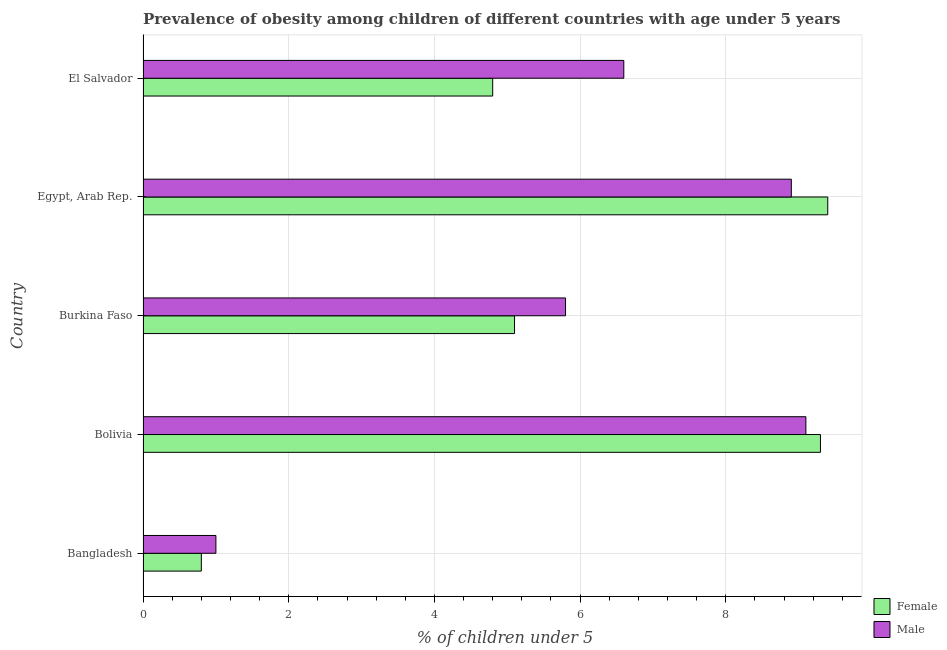How many groups of bars are there?
Your response must be concise. 5. Are the number of bars on each tick of the Y-axis equal?
Give a very brief answer. Yes. In how many cases, is the number of bars for a given country not equal to the number of legend labels?
Provide a short and direct response. 0. Across all countries, what is the maximum percentage of obese female children?
Provide a short and direct response. 9.4. In which country was the percentage of obese female children maximum?
Ensure brevity in your answer.  Egypt, Arab Rep. In which country was the percentage of obese female children minimum?
Give a very brief answer. Bangladesh. What is the total percentage of obese male children in the graph?
Provide a succinct answer. 31.4. What is the difference between the percentage of obese female children in Bangladesh and that in Egypt, Arab Rep.?
Ensure brevity in your answer.  -8.6. What is the difference between the percentage of obese female children in Bolivia and the percentage of obese male children in Burkina Faso?
Make the answer very short. 3.5. What is the average percentage of obese male children per country?
Your answer should be compact. 6.28. What is the difference between the percentage of obese male children and percentage of obese female children in Bangladesh?
Offer a very short reply. 0.2. What is the ratio of the percentage of obese male children in Burkina Faso to that in Egypt, Arab Rep.?
Ensure brevity in your answer.  0.65. What is the difference between the highest and the lowest percentage of obese female children?
Provide a short and direct response. 8.6. Is the sum of the percentage of obese female children in Bangladesh and Bolivia greater than the maximum percentage of obese male children across all countries?
Offer a very short reply. Yes. Are all the bars in the graph horizontal?
Make the answer very short. Yes. What is the difference between two consecutive major ticks on the X-axis?
Your response must be concise. 2. Does the graph contain any zero values?
Ensure brevity in your answer.  No. Where does the legend appear in the graph?
Make the answer very short. Bottom right. How many legend labels are there?
Give a very brief answer. 2. What is the title of the graph?
Keep it short and to the point. Prevalence of obesity among children of different countries with age under 5 years. What is the label or title of the X-axis?
Provide a short and direct response.  % of children under 5. What is the label or title of the Y-axis?
Your answer should be very brief. Country. What is the  % of children under 5 of Female in Bangladesh?
Provide a short and direct response. 0.8. What is the  % of children under 5 in Male in Bangladesh?
Give a very brief answer. 1. What is the  % of children under 5 in Female in Bolivia?
Offer a very short reply. 9.3. What is the  % of children under 5 in Male in Bolivia?
Your response must be concise. 9.1. What is the  % of children under 5 of Female in Burkina Faso?
Your answer should be compact. 5.1. What is the  % of children under 5 in Male in Burkina Faso?
Your response must be concise. 5.8. What is the  % of children under 5 in Female in Egypt, Arab Rep.?
Your answer should be very brief. 9.4. What is the  % of children under 5 in Male in Egypt, Arab Rep.?
Ensure brevity in your answer.  8.9. What is the  % of children under 5 of Female in El Salvador?
Offer a very short reply. 4.8. What is the  % of children under 5 of Male in El Salvador?
Provide a short and direct response. 6.6. Across all countries, what is the maximum  % of children under 5 in Female?
Keep it short and to the point. 9.4. Across all countries, what is the maximum  % of children under 5 in Male?
Your answer should be compact. 9.1. Across all countries, what is the minimum  % of children under 5 in Female?
Your answer should be compact. 0.8. Across all countries, what is the minimum  % of children under 5 of Male?
Keep it short and to the point. 1. What is the total  % of children under 5 in Female in the graph?
Offer a terse response. 29.4. What is the total  % of children under 5 in Male in the graph?
Offer a very short reply. 31.4. What is the difference between the  % of children under 5 in Female in Bangladesh and that in Bolivia?
Make the answer very short. -8.5. What is the difference between the  % of children under 5 of Female in Bangladesh and that in Burkina Faso?
Your answer should be very brief. -4.3. What is the difference between the  % of children under 5 of Male in Bangladesh and that in Egypt, Arab Rep.?
Provide a succinct answer. -7.9. What is the difference between the  % of children under 5 of Female in Bolivia and that in El Salvador?
Your answer should be very brief. 4.5. What is the difference between the  % of children under 5 of Male in Bolivia and that in El Salvador?
Provide a succinct answer. 2.5. What is the difference between the  % of children under 5 of Female in Burkina Faso and that in Egypt, Arab Rep.?
Provide a short and direct response. -4.3. What is the difference between the  % of children under 5 in Male in Burkina Faso and that in Egypt, Arab Rep.?
Provide a succinct answer. -3.1. What is the difference between the  % of children under 5 in Female in Burkina Faso and that in El Salvador?
Provide a succinct answer. 0.3. What is the difference between the  % of children under 5 in Female in Egypt, Arab Rep. and that in El Salvador?
Ensure brevity in your answer.  4.6. What is the difference between the  % of children under 5 in Female in Bangladesh and the  % of children under 5 in Male in Burkina Faso?
Keep it short and to the point. -5. What is the difference between the  % of children under 5 of Female in Bangladesh and the  % of children under 5 of Male in El Salvador?
Offer a very short reply. -5.8. What is the difference between the  % of children under 5 in Female in Bolivia and the  % of children under 5 in Male in Egypt, Arab Rep.?
Your answer should be very brief. 0.4. What is the difference between the  % of children under 5 of Female in Burkina Faso and the  % of children under 5 of Male in El Salvador?
Offer a terse response. -1.5. What is the average  % of children under 5 in Female per country?
Provide a succinct answer. 5.88. What is the average  % of children under 5 of Male per country?
Provide a short and direct response. 6.28. What is the difference between the  % of children under 5 of Female and  % of children under 5 of Male in Bangladesh?
Your response must be concise. -0.2. What is the difference between the  % of children under 5 in Female and  % of children under 5 in Male in Bolivia?
Your answer should be very brief. 0.2. What is the difference between the  % of children under 5 of Female and  % of children under 5 of Male in Egypt, Arab Rep.?
Ensure brevity in your answer.  0.5. What is the difference between the  % of children under 5 of Female and  % of children under 5 of Male in El Salvador?
Your answer should be very brief. -1.8. What is the ratio of the  % of children under 5 of Female in Bangladesh to that in Bolivia?
Your answer should be very brief. 0.09. What is the ratio of the  % of children under 5 of Male in Bangladesh to that in Bolivia?
Provide a short and direct response. 0.11. What is the ratio of the  % of children under 5 of Female in Bangladesh to that in Burkina Faso?
Make the answer very short. 0.16. What is the ratio of the  % of children under 5 in Male in Bangladesh to that in Burkina Faso?
Provide a short and direct response. 0.17. What is the ratio of the  % of children under 5 in Female in Bangladesh to that in Egypt, Arab Rep.?
Provide a short and direct response. 0.09. What is the ratio of the  % of children under 5 in Male in Bangladesh to that in Egypt, Arab Rep.?
Make the answer very short. 0.11. What is the ratio of the  % of children under 5 of Male in Bangladesh to that in El Salvador?
Provide a short and direct response. 0.15. What is the ratio of the  % of children under 5 of Female in Bolivia to that in Burkina Faso?
Provide a short and direct response. 1.82. What is the ratio of the  % of children under 5 of Male in Bolivia to that in Burkina Faso?
Offer a very short reply. 1.57. What is the ratio of the  % of children under 5 in Female in Bolivia to that in Egypt, Arab Rep.?
Provide a succinct answer. 0.99. What is the ratio of the  % of children under 5 in Male in Bolivia to that in Egypt, Arab Rep.?
Your answer should be compact. 1.02. What is the ratio of the  % of children under 5 of Female in Bolivia to that in El Salvador?
Your answer should be very brief. 1.94. What is the ratio of the  % of children under 5 in Male in Bolivia to that in El Salvador?
Ensure brevity in your answer.  1.38. What is the ratio of the  % of children under 5 of Female in Burkina Faso to that in Egypt, Arab Rep.?
Offer a very short reply. 0.54. What is the ratio of the  % of children under 5 in Male in Burkina Faso to that in Egypt, Arab Rep.?
Make the answer very short. 0.65. What is the ratio of the  % of children under 5 in Male in Burkina Faso to that in El Salvador?
Your answer should be very brief. 0.88. What is the ratio of the  % of children under 5 of Female in Egypt, Arab Rep. to that in El Salvador?
Your answer should be very brief. 1.96. What is the ratio of the  % of children under 5 in Male in Egypt, Arab Rep. to that in El Salvador?
Offer a terse response. 1.35. What is the difference between the highest and the second highest  % of children under 5 in Female?
Your answer should be compact. 0.1. What is the difference between the highest and the lowest  % of children under 5 in Male?
Provide a succinct answer. 8.1. 